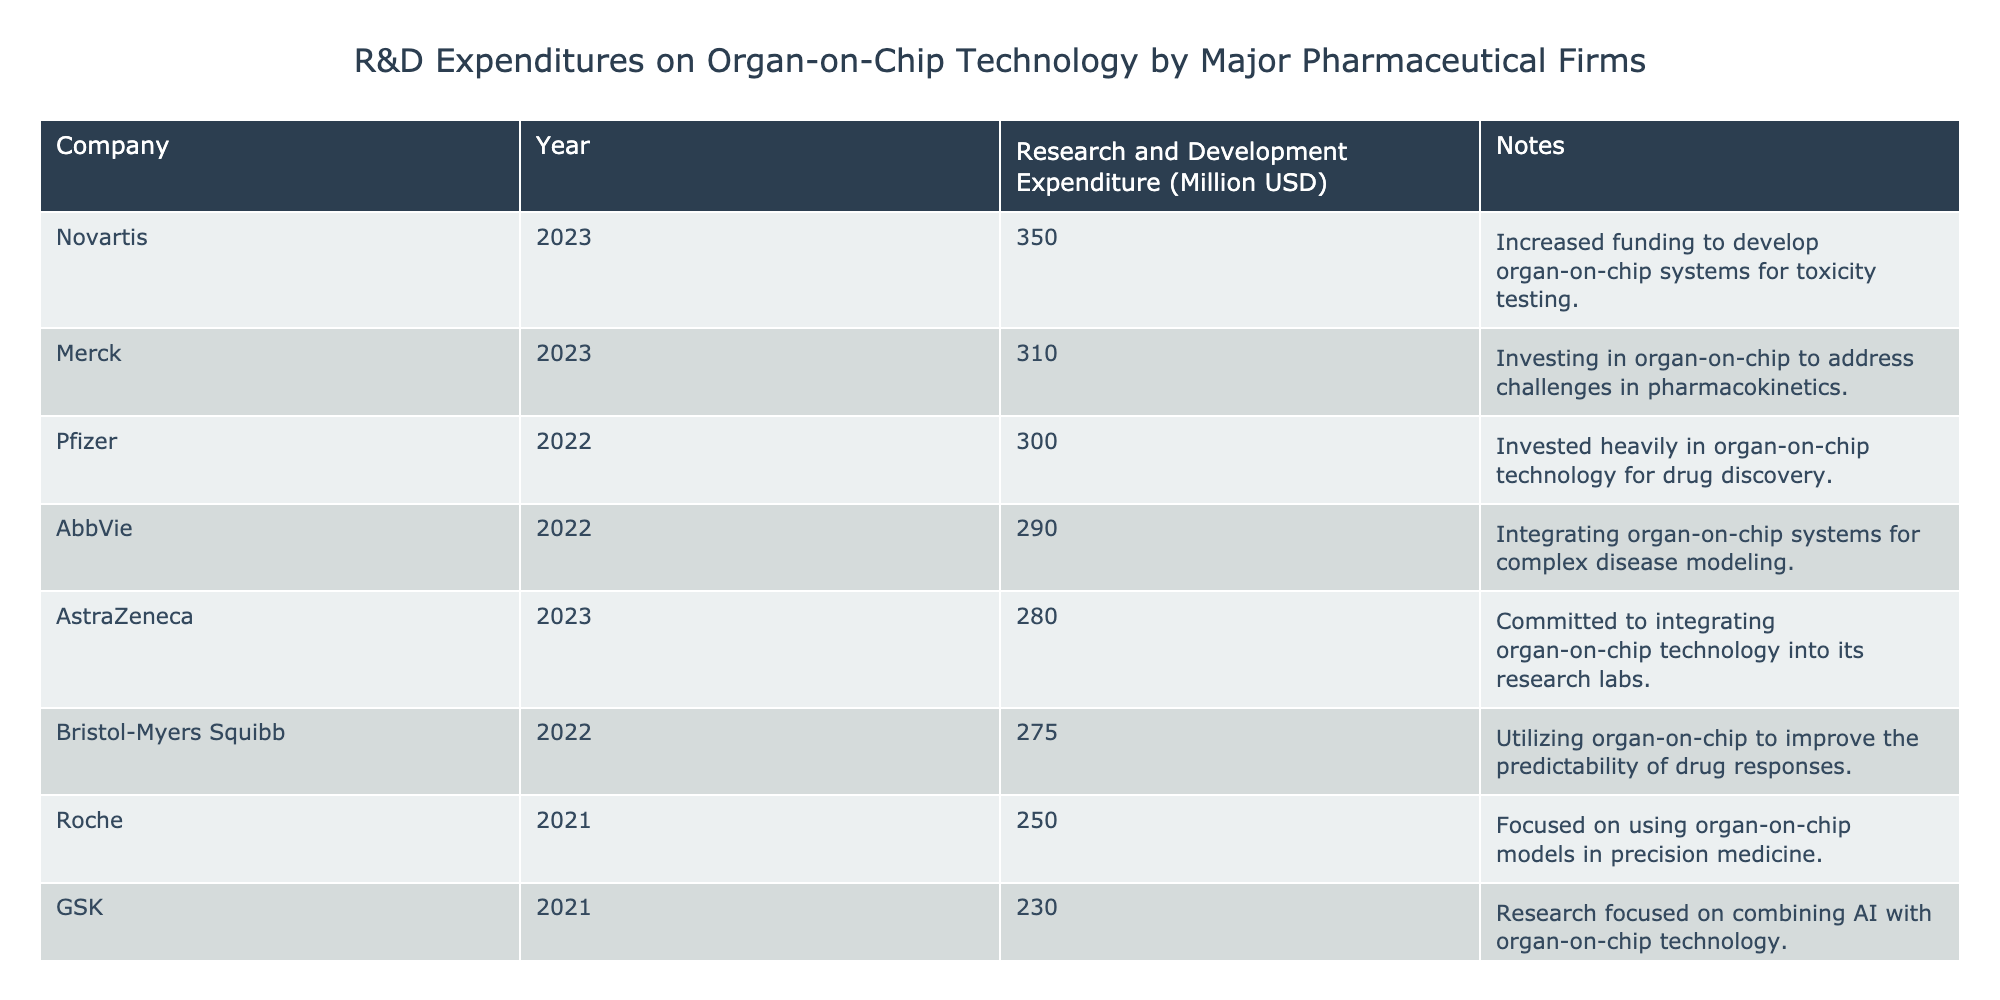What is the highest research and development expenditure on organ-on-chip technology by a company in 2023? In the table, we look at the year 2023 and find that Novartis has the highest expenditure at 350 million USD for that year.
Answer: 350 million USD Which company has the lowest research and development expenditure in 2022? In the 2022 section of the table, we observe that Johnson & Johnson has the lowest expenditure at 200 million USD compared to the other companies listed for that year.
Answer: 200 million USD What is the total research and development expenditure on organ-on-chip technology by all companies in 2021? Adding up the expenditures for the year 2021: Roche (250) + Sanofi (220) + GSK (230) = 700 million USD. Therefore, the total expenditure for that year is 700 million USD.
Answer: 700 million USD Did AstraZeneca invest more in 2023 compared to Novartis in 2023? In 2023, AstraZeneca's expenditure is 280 million USD while Novartis's is 350 million USD. Therefore, AstraZeneca did not invest more than Novartis in 2023.
Answer: No What was the average research and development expenditure across all companies for the year 2022? To find the average for 2022, we add up the expenditures: Pfizer (300) + Johnson & Johnson (200) + Bristol-Myers Squibb (275) + AbbVie (290) = 1065 million USD. Dividing by the 4 companies gives an average of 1065 million USD / 4 = 266.25 million USD.
Answer: 266.25 million USD How many companies invested over 250 million USD in 2022? In 2022, the expenditures were: Pfizer (300), Bristol-Myers Squibb (275), and AbbVie (290). This gives us 3 companies that invested over 250 million USD in that year.
Answer: 3 companies Is it true that GSK's expenditure in 2021 is higher than Roche's in the same year? GSK's expenditure in 2021 is 230 million USD and Roche's is 250 million USD. Therefore, GSK's expenditure is not higher than Roche's.
Answer: No Which company increased its spending the most from 2021 to 2023? Looking at the expenditures, Roche spent 250 million USD in 2021 and did not report in 2023, while Novartis's spending went from 0 to 350 million USD. The greatest increase from a previous value to now is Novartis.
Answer: Novartis What is the combined research and development expenditure for Johnson & Johnson and AstraZeneca in 2022 and 2023? Johnson & Johnson spent 200 million USD in 2022 and AstraZeneca spent 280 million USD in 2023. Their combined expenditure is 200 + 280 = 480 million USD.
Answer: 480 million USD 